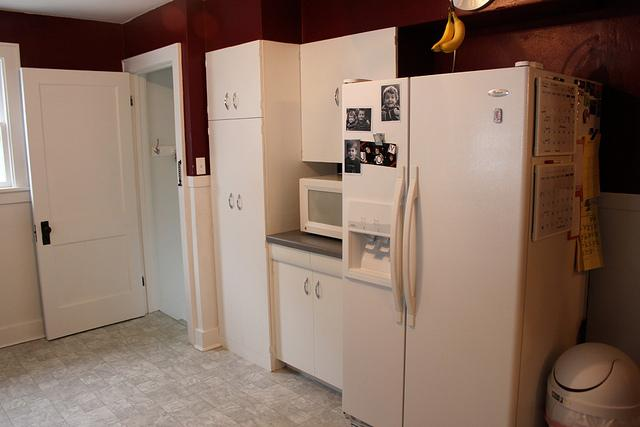What is on the side of the refrigerator? Please explain your reasoning. garbage disposal. There is a bin next to the fridge that is used for disposal of garbage. 